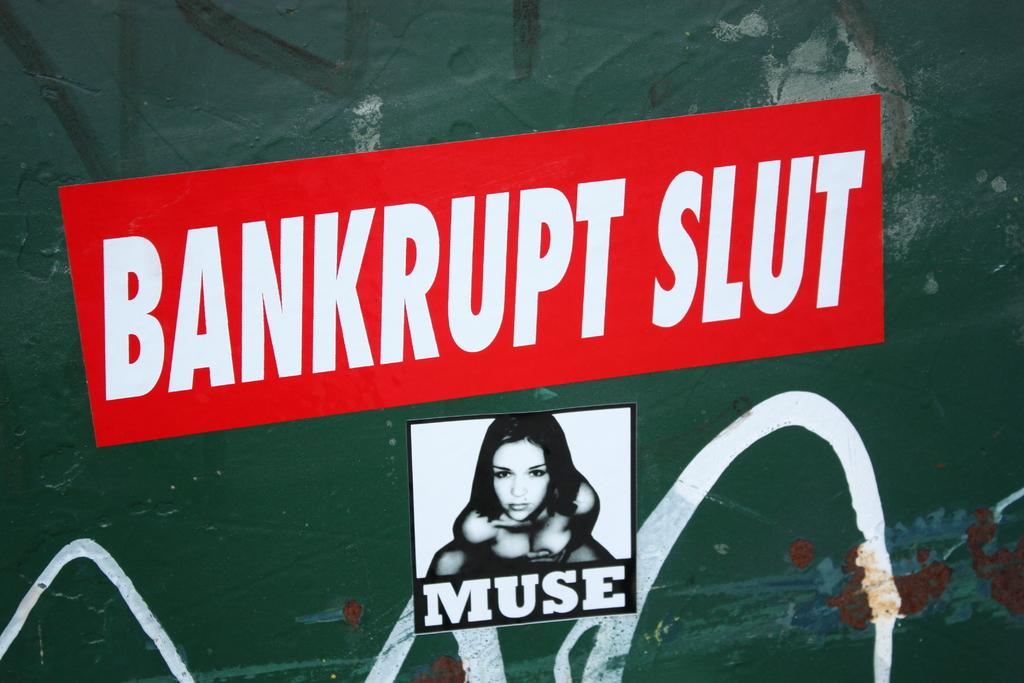<image>
Give a short and clear explanation of the subsequent image. Red sticker with white text that says "Bankrupt Slut". 